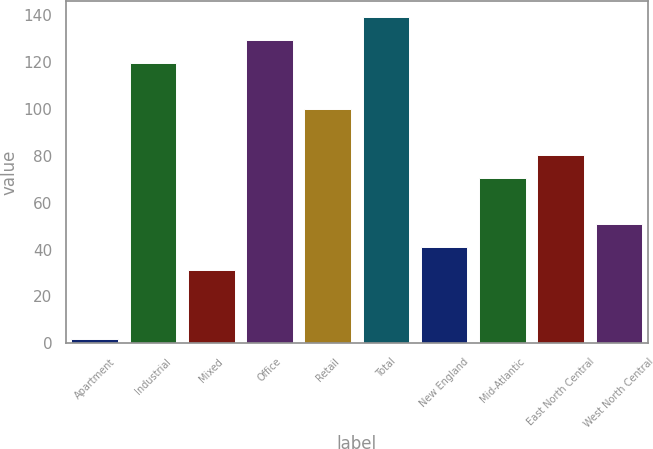Convert chart. <chart><loc_0><loc_0><loc_500><loc_500><bar_chart><fcel>Apartment<fcel>Industrial<fcel>Mixed<fcel>Office<fcel>Retail<fcel>Total<fcel>New England<fcel>Mid-Atlantic<fcel>East North Central<fcel>West North Central<nl><fcel>1.8<fcel>119.64<fcel>31.26<fcel>129.46<fcel>100<fcel>139.28<fcel>41.08<fcel>70.54<fcel>80.36<fcel>50.9<nl></chart> 